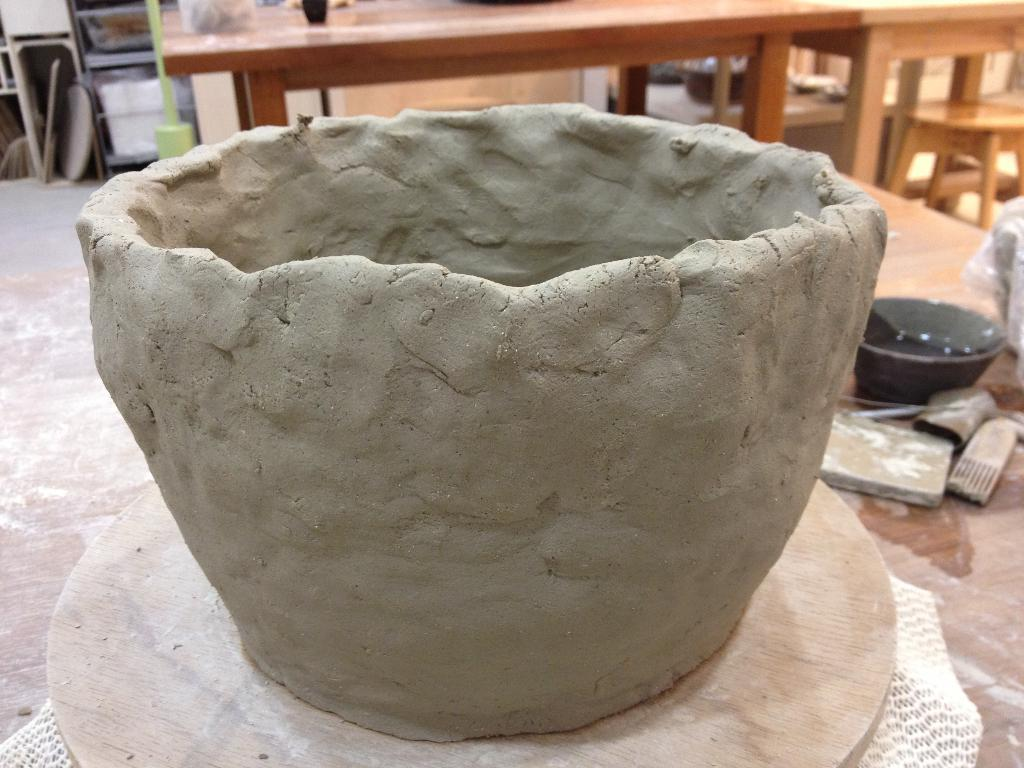What material is the product in the image made of? The product in the image is made of clay. What else can be seen on the right side of the image? There is a bowl on the right side of the image. What type of lumber is used to create the product in the image? The product in the image is made of clay, not lumber. Is there any indication of war or conflict in the image? No, there is no indication of war or conflict in the image. 